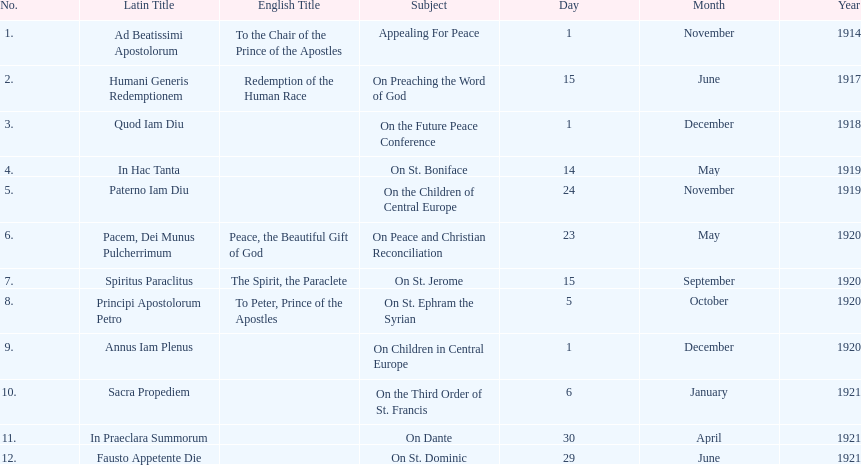Other than january how many encyclicals were in 1921? 2. 